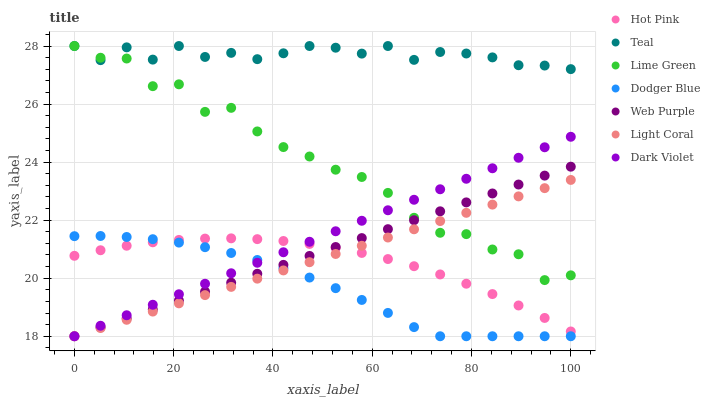Does Dodger Blue have the minimum area under the curve?
Answer yes or no. Yes. Does Teal have the maximum area under the curve?
Answer yes or no. Yes. Does Dark Violet have the minimum area under the curve?
Answer yes or no. No. Does Dark Violet have the maximum area under the curve?
Answer yes or no. No. Is Web Purple the smoothest?
Answer yes or no. Yes. Is Lime Green the roughest?
Answer yes or no. Yes. Is Dark Violet the smoothest?
Answer yes or no. No. Is Dark Violet the roughest?
Answer yes or no. No. Does Dark Violet have the lowest value?
Answer yes or no. Yes. Does Teal have the lowest value?
Answer yes or no. No. Does Lime Green have the highest value?
Answer yes or no. Yes. Does Dark Violet have the highest value?
Answer yes or no. No. Is Hot Pink less than Teal?
Answer yes or no. Yes. Is Teal greater than Web Purple?
Answer yes or no. Yes. Does Web Purple intersect Dodger Blue?
Answer yes or no. Yes. Is Web Purple less than Dodger Blue?
Answer yes or no. No. Is Web Purple greater than Dodger Blue?
Answer yes or no. No. Does Hot Pink intersect Teal?
Answer yes or no. No. 